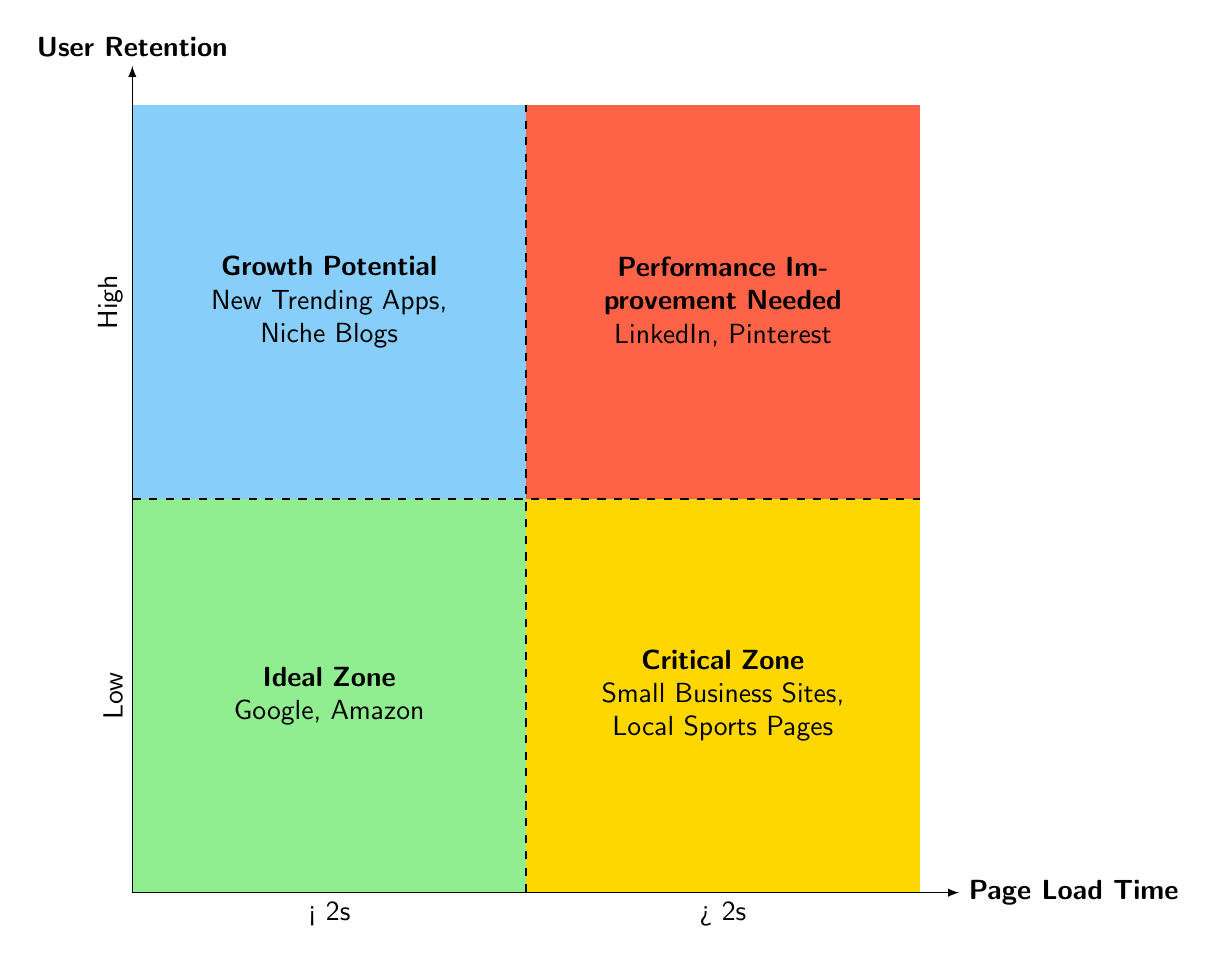What are the example sites in the Ideal Zone? The Ideal Zone on the chart includes examples like Google and Amazon, which are specifically mentioned in the quadrant's label.
Answer: Google, Amazon What is the page load time threshold that distinguishes the quadrants? The quadrants are split based on the 2 seconds page load time threshold. For example, left of this line (<2s) distinguishes the ideal scenario from the critical zone.
Answer: 2 seconds Which quadrant represents sites with high user retention and high page load time? The Performance Improvement Needed quadrant represents sites where the page load time exceeds 2 seconds but still has a high user retention rate, like LinkedIn and Pinterest.
Answer: Performance Improvement Needed In which zone do small business sites fall according to the chart? Small business sites are classified in the Critical Zone, where they exhibit high page load times (>2s) and low user retention. This is indicated by the specific examples provided in the quadrant.
Answer: Critical Zone How many quadrants are there in the diagram? The diagram clearly displays four quadrants, each with distinct characteristics relating to page load time and user retention. This can be counted visually by observing the labeled areas.
Answer: Four What type of sites are found in the Growth Potential quadrant? The Growth Potential quadrant features sites like New Trending Apps and Niche Blogs, as mentioned in its description. This points to their characteristic of low user retention despite having good page load times (<2s).
Answer: New Trending Apps, Niche Blogs What is the primary focus of the diagram? The primary focus is on the relationship between Page Load Time and User Retention, illustrated through the division of quadrants based on these two metrics.
Answer: Page Load Time vs User Retention Which quadrant shows the worst performance in terms of both metrics? The Critical Zone indicates the worst performance by showcasing entities that have both high page load times and low user retention, symbolizing a significant area for concern.
Answer: Critical Zone 